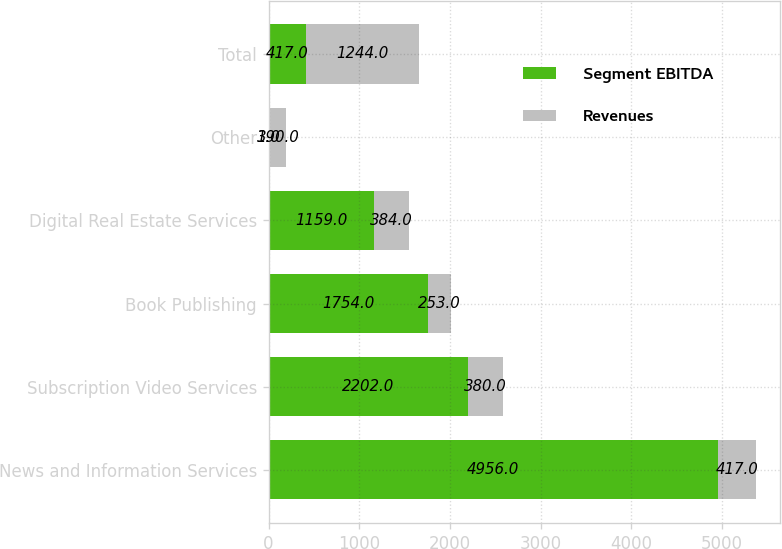<chart> <loc_0><loc_0><loc_500><loc_500><stacked_bar_chart><ecel><fcel>News and Information Services<fcel>Subscription Video Services<fcel>Book Publishing<fcel>Digital Real Estate Services<fcel>Other<fcel>Total<nl><fcel>Segment EBITDA<fcel>4956<fcel>2202<fcel>1754<fcel>1159<fcel>3<fcel>417<nl><fcel>Revenues<fcel>417<fcel>380<fcel>253<fcel>384<fcel>190<fcel>1244<nl></chart> 